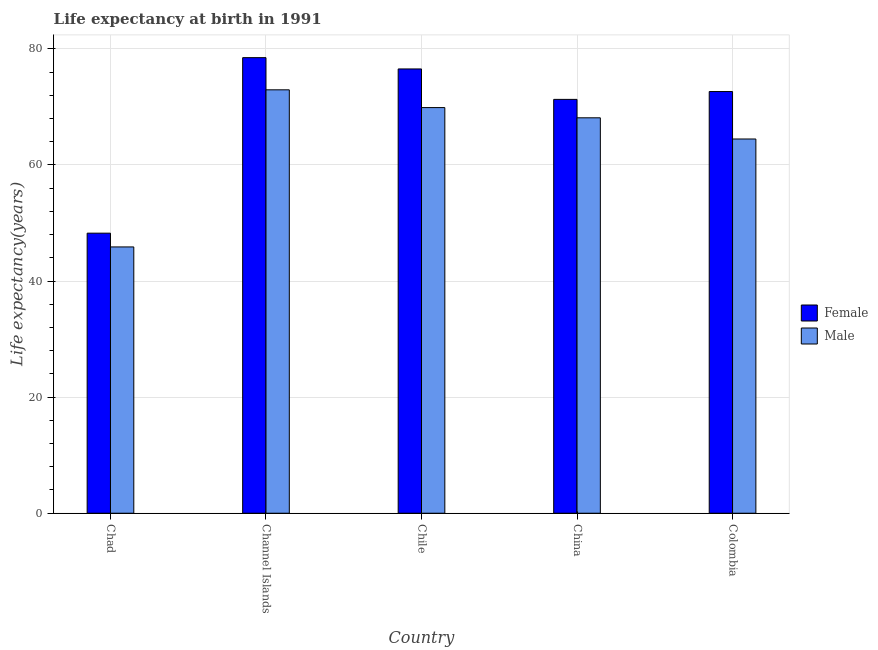How many groups of bars are there?
Provide a succinct answer. 5. Are the number of bars on each tick of the X-axis equal?
Provide a succinct answer. Yes. How many bars are there on the 5th tick from the left?
Your answer should be very brief. 2. What is the label of the 1st group of bars from the left?
Ensure brevity in your answer.  Chad. What is the life expectancy(female) in Chile?
Your answer should be compact. 76.53. Across all countries, what is the maximum life expectancy(male)?
Offer a terse response. 72.93. Across all countries, what is the minimum life expectancy(female)?
Your answer should be very brief. 48.24. In which country was the life expectancy(female) maximum?
Ensure brevity in your answer.  Channel Islands. In which country was the life expectancy(female) minimum?
Your answer should be compact. Chad. What is the total life expectancy(male) in the graph?
Ensure brevity in your answer.  321.26. What is the difference between the life expectancy(female) in Chad and that in Channel Islands?
Your answer should be very brief. -30.23. What is the difference between the life expectancy(male) in China and the life expectancy(female) in Colombia?
Ensure brevity in your answer.  -4.52. What is the average life expectancy(female) per country?
Ensure brevity in your answer.  69.43. What is the difference between the life expectancy(male) and life expectancy(female) in Chad?
Provide a short and direct response. -2.37. In how many countries, is the life expectancy(female) greater than 44 years?
Make the answer very short. 5. What is the ratio of the life expectancy(female) in Chad to that in Colombia?
Give a very brief answer. 0.66. Is the life expectancy(female) in Channel Islands less than that in Chile?
Offer a terse response. No. Is the difference between the life expectancy(female) in Channel Islands and Chile greater than the difference between the life expectancy(male) in Channel Islands and Chile?
Keep it short and to the point. No. What is the difference between the highest and the second highest life expectancy(female)?
Provide a succinct answer. 1.94. What is the difference between the highest and the lowest life expectancy(male)?
Offer a very short reply. 27.06. In how many countries, is the life expectancy(male) greater than the average life expectancy(male) taken over all countries?
Offer a very short reply. 4. Is the sum of the life expectancy(female) in Chad and China greater than the maximum life expectancy(male) across all countries?
Your response must be concise. Yes. How many bars are there?
Your answer should be very brief. 10. How many countries are there in the graph?
Your answer should be compact. 5. Does the graph contain any zero values?
Offer a very short reply. No. What is the title of the graph?
Provide a short and direct response. Life expectancy at birth in 1991. Does "Export" appear as one of the legend labels in the graph?
Provide a succinct answer. No. What is the label or title of the X-axis?
Keep it short and to the point. Country. What is the label or title of the Y-axis?
Ensure brevity in your answer.  Life expectancy(years). What is the Life expectancy(years) in Female in Chad?
Give a very brief answer. 48.24. What is the Life expectancy(years) in Male in Chad?
Your response must be concise. 45.87. What is the Life expectancy(years) of Female in Channel Islands?
Give a very brief answer. 78.47. What is the Life expectancy(years) of Male in Channel Islands?
Your response must be concise. 72.93. What is the Life expectancy(years) in Female in Chile?
Provide a succinct answer. 76.53. What is the Life expectancy(years) in Male in Chile?
Give a very brief answer. 69.88. What is the Life expectancy(years) of Female in China?
Your answer should be compact. 71.29. What is the Life expectancy(years) in Male in China?
Make the answer very short. 68.11. What is the Life expectancy(years) in Female in Colombia?
Your response must be concise. 72.64. What is the Life expectancy(years) of Male in Colombia?
Offer a very short reply. 64.46. Across all countries, what is the maximum Life expectancy(years) in Female?
Your response must be concise. 78.47. Across all countries, what is the maximum Life expectancy(years) of Male?
Your answer should be compact. 72.93. Across all countries, what is the minimum Life expectancy(years) of Female?
Offer a very short reply. 48.24. Across all countries, what is the minimum Life expectancy(years) in Male?
Provide a short and direct response. 45.87. What is the total Life expectancy(years) of Female in the graph?
Make the answer very short. 347.17. What is the total Life expectancy(years) in Male in the graph?
Your answer should be compact. 321.26. What is the difference between the Life expectancy(years) in Female in Chad and that in Channel Islands?
Make the answer very short. -30.23. What is the difference between the Life expectancy(years) in Male in Chad and that in Channel Islands?
Keep it short and to the point. -27.06. What is the difference between the Life expectancy(years) of Female in Chad and that in Chile?
Your answer should be very brief. -28.29. What is the difference between the Life expectancy(years) in Male in Chad and that in Chile?
Your answer should be very brief. -24. What is the difference between the Life expectancy(years) in Female in Chad and that in China?
Offer a very short reply. -23.05. What is the difference between the Life expectancy(years) of Male in Chad and that in China?
Offer a very short reply. -22.24. What is the difference between the Life expectancy(years) in Female in Chad and that in Colombia?
Give a very brief answer. -24.4. What is the difference between the Life expectancy(years) of Male in Chad and that in Colombia?
Your response must be concise. -18.59. What is the difference between the Life expectancy(years) of Female in Channel Islands and that in Chile?
Keep it short and to the point. 1.95. What is the difference between the Life expectancy(years) in Male in Channel Islands and that in Chile?
Give a very brief answer. 3.06. What is the difference between the Life expectancy(years) in Female in Channel Islands and that in China?
Your answer should be very brief. 7.19. What is the difference between the Life expectancy(years) in Male in Channel Islands and that in China?
Offer a terse response. 4.82. What is the difference between the Life expectancy(years) of Female in Channel Islands and that in Colombia?
Provide a succinct answer. 5.84. What is the difference between the Life expectancy(years) of Male in Channel Islands and that in Colombia?
Your answer should be very brief. 8.47. What is the difference between the Life expectancy(years) in Female in Chile and that in China?
Make the answer very short. 5.24. What is the difference between the Life expectancy(years) of Male in Chile and that in China?
Offer a terse response. 1.76. What is the difference between the Life expectancy(years) in Female in Chile and that in Colombia?
Your response must be concise. 3.89. What is the difference between the Life expectancy(years) of Male in Chile and that in Colombia?
Keep it short and to the point. 5.41. What is the difference between the Life expectancy(years) in Female in China and that in Colombia?
Ensure brevity in your answer.  -1.35. What is the difference between the Life expectancy(years) in Male in China and that in Colombia?
Keep it short and to the point. 3.65. What is the difference between the Life expectancy(years) in Female in Chad and the Life expectancy(years) in Male in Channel Islands?
Your answer should be compact. -24.69. What is the difference between the Life expectancy(years) of Female in Chad and the Life expectancy(years) of Male in Chile?
Your answer should be compact. -21.63. What is the difference between the Life expectancy(years) in Female in Chad and the Life expectancy(years) in Male in China?
Your answer should be compact. -19.87. What is the difference between the Life expectancy(years) of Female in Chad and the Life expectancy(years) of Male in Colombia?
Offer a very short reply. -16.22. What is the difference between the Life expectancy(years) in Female in Channel Islands and the Life expectancy(years) in Male in China?
Your answer should be compact. 10.36. What is the difference between the Life expectancy(years) of Female in Channel Islands and the Life expectancy(years) of Male in Colombia?
Provide a short and direct response. 14.01. What is the difference between the Life expectancy(years) of Female in Chile and the Life expectancy(years) of Male in China?
Provide a succinct answer. 8.42. What is the difference between the Life expectancy(years) in Female in Chile and the Life expectancy(years) in Male in Colombia?
Provide a succinct answer. 12.07. What is the difference between the Life expectancy(years) of Female in China and the Life expectancy(years) of Male in Colombia?
Provide a short and direct response. 6.82. What is the average Life expectancy(years) of Female per country?
Ensure brevity in your answer.  69.43. What is the average Life expectancy(years) of Male per country?
Make the answer very short. 64.25. What is the difference between the Life expectancy(years) of Female and Life expectancy(years) of Male in Chad?
Provide a succinct answer. 2.37. What is the difference between the Life expectancy(years) of Female and Life expectancy(years) of Male in Channel Islands?
Your answer should be very brief. 5.54. What is the difference between the Life expectancy(years) in Female and Life expectancy(years) in Male in Chile?
Provide a succinct answer. 6.66. What is the difference between the Life expectancy(years) of Female and Life expectancy(years) of Male in China?
Give a very brief answer. 3.17. What is the difference between the Life expectancy(years) of Female and Life expectancy(years) of Male in Colombia?
Make the answer very short. 8.17. What is the ratio of the Life expectancy(years) of Female in Chad to that in Channel Islands?
Your answer should be very brief. 0.61. What is the ratio of the Life expectancy(years) of Male in Chad to that in Channel Islands?
Give a very brief answer. 0.63. What is the ratio of the Life expectancy(years) in Female in Chad to that in Chile?
Provide a short and direct response. 0.63. What is the ratio of the Life expectancy(years) of Male in Chad to that in Chile?
Offer a terse response. 0.66. What is the ratio of the Life expectancy(years) of Female in Chad to that in China?
Offer a terse response. 0.68. What is the ratio of the Life expectancy(years) in Male in Chad to that in China?
Make the answer very short. 0.67. What is the ratio of the Life expectancy(years) in Female in Chad to that in Colombia?
Provide a succinct answer. 0.66. What is the ratio of the Life expectancy(years) of Male in Chad to that in Colombia?
Give a very brief answer. 0.71. What is the ratio of the Life expectancy(years) of Female in Channel Islands to that in Chile?
Provide a short and direct response. 1.03. What is the ratio of the Life expectancy(years) of Male in Channel Islands to that in Chile?
Your response must be concise. 1.04. What is the ratio of the Life expectancy(years) of Female in Channel Islands to that in China?
Offer a terse response. 1.1. What is the ratio of the Life expectancy(years) of Male in Channel Islands to that in China?
Your response must be concise. 1.07. What is the ratio of the Life expectancy(years) of Female in Channel Islands to that in Colombia?
Ensure brevity in your answer.  1.08. What is the ratio of the Life expectancy(years) of Male in Channel Islands to that in Colombia?
Give a very brief answer. 1.13. What is the ratio of the Life expectancy(years) in Female in Chile to that in China?
Offer a very short reply. 1.07. What is the ratio of the Life expectancy(years) of Male in Chile to that in China?
Provide a succinct answer. 1.03. What is the ratio of the Life expectancy(years) in Female in Chile to that in Colombia?
Ensure brevity in your answer.  1.05. What is the ratio of the Life expectancy(years) of Male in Chile to that in Colombia?
Your answer should be very brief. 1.08. What is the ratio of the Life expectancy(years) in Female in China to that in Colombia?
Make the answer very short. 0.98. What is the ratio of the Life expectancy(years) of Male in China to that in Colombia?
Provide a succinct answer. 1.06. What is the difference between the highest and the second highest Life expectancy(years) in Female?
Your answer should be compact. 1.95. What is the difference between the highest and the second highest Life expectancy(years) in Male?
Offer a very short reply. 3.06. What is the difference between the highest and the lowest Life expectancy(years) in Female?
Provide a succinct answer. 30.23. What is the difference between the highest and the lowest Life expectancy(years) in Male?
Keep it short and to the point. 27.06. 